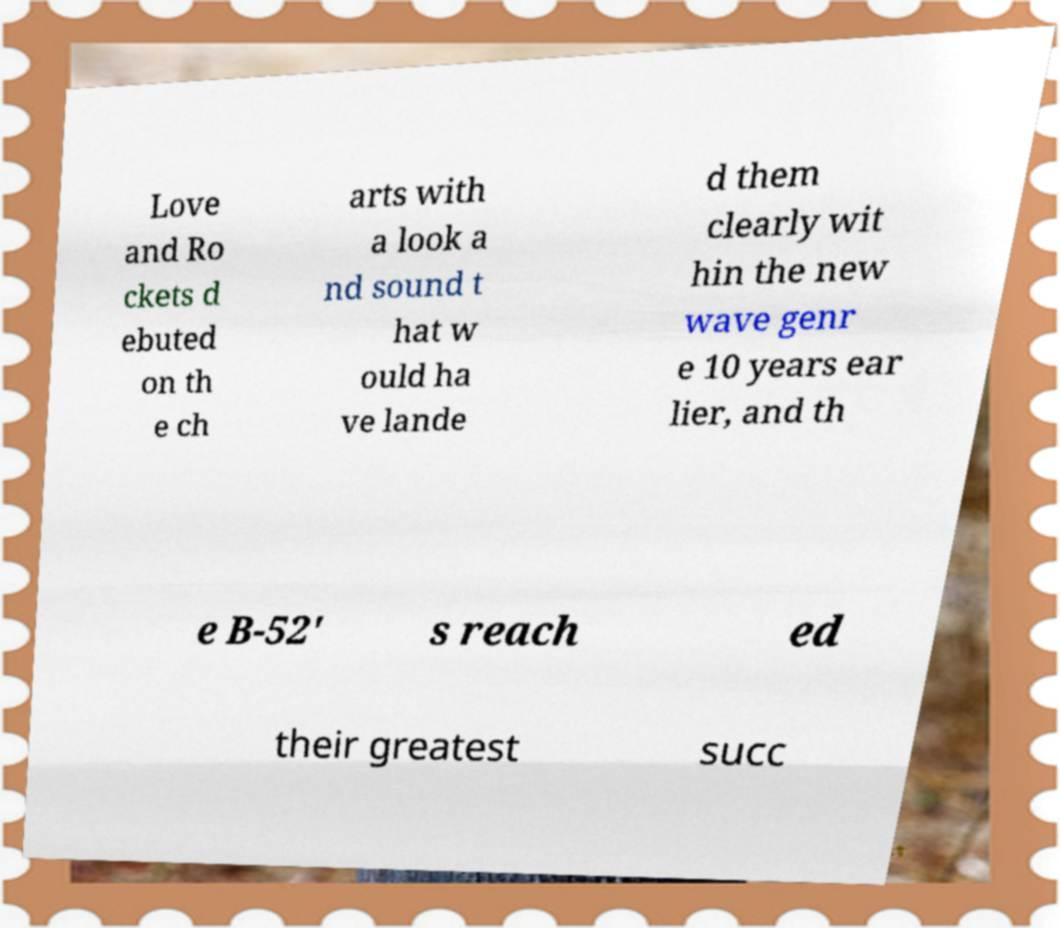What messages or text are displayed in this image? I need them in a readable, typed format. Love and Ro ckets d ebuted on th e ch arts with a look a nd sound t hat w ould ha ve lande d them clearly wit hin the new wave genr e 10 years ear lier, and th e B-52' s reach ed their greatest succ 